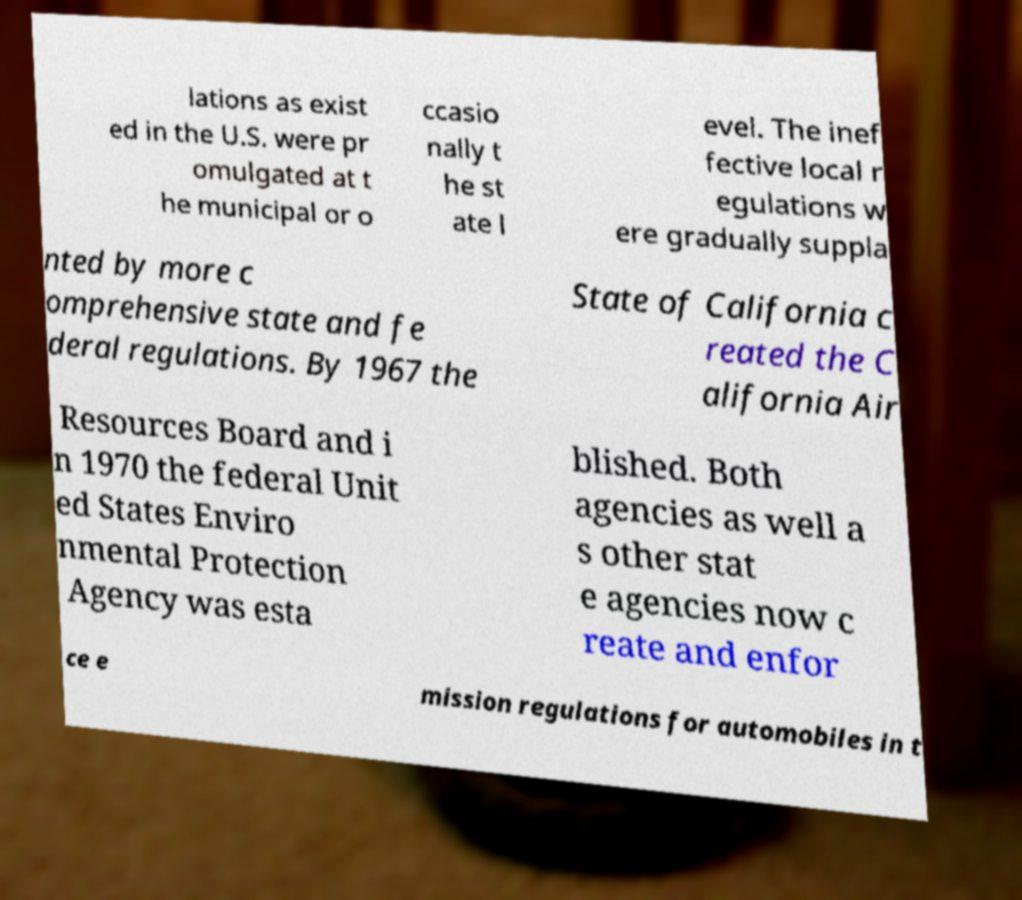Please read and relay the text visible in this image. What does it say? lations as exist ed in the U.S. were pr omulgated at t he municipal or o ccasio nally t he st ate l evel. The inef fective local r egulations w ere gradually suppla nted by more c omprehensive state and fe deral regulations. By 1967 the State of California c reated the C alifornia Air Resources Board and i n 1970 the federal Unit ed States Enviro nmental Protection Agency was esta blished. Both agencies as well a s other stat e agencies now c reate and enfor ce e mission regulations for automobiles in t 